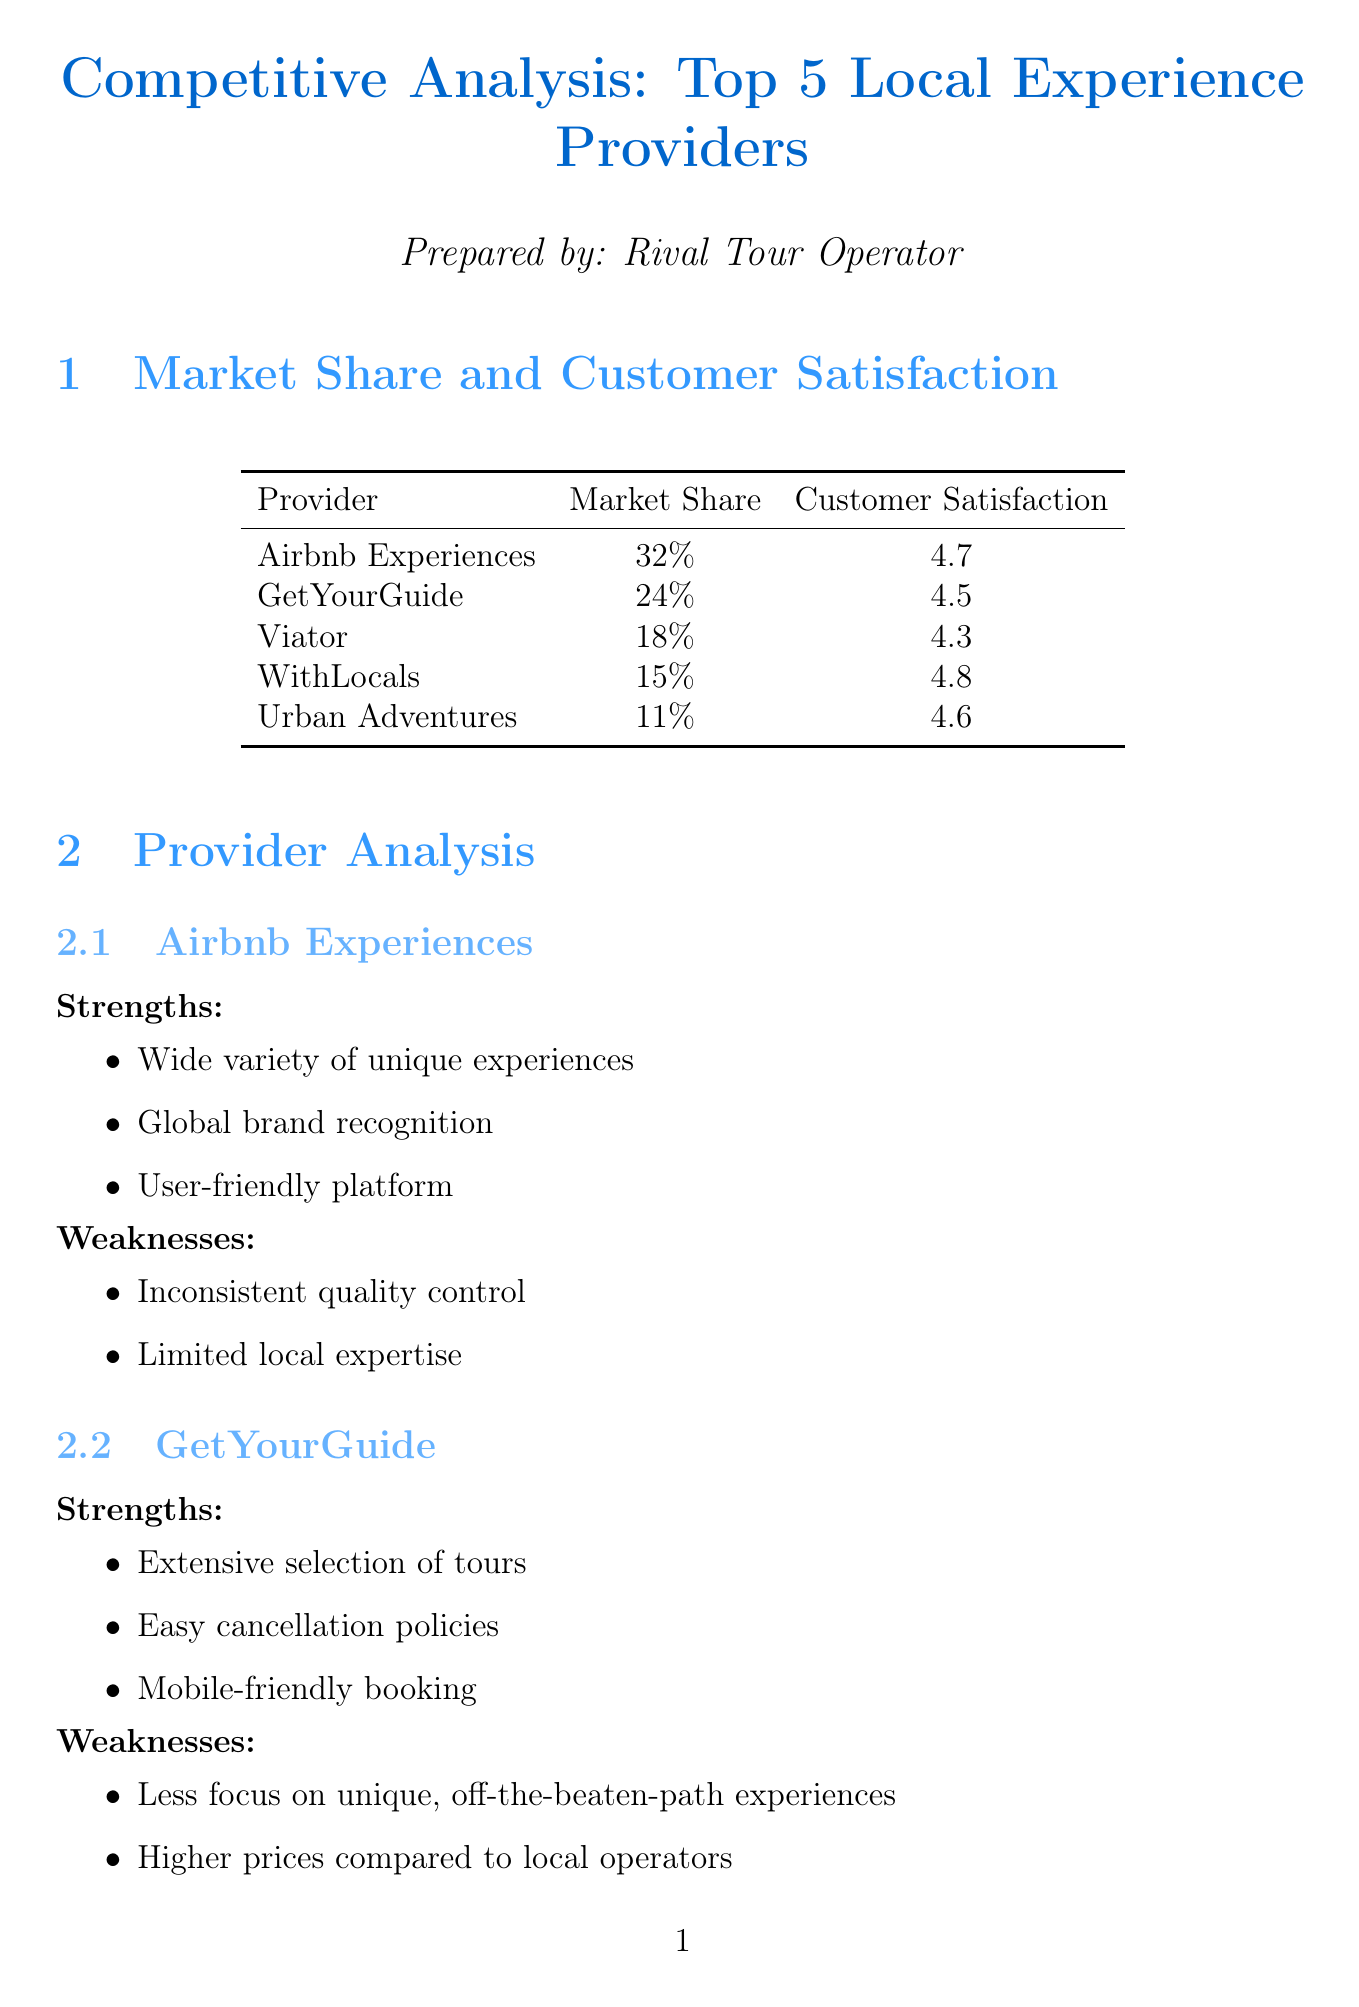What is the market share of Airbnb Experiences? The market share of Airbnb Experiences is explicitly stated in the document.
Answer: 32% Which provider has the highest customer satisfaction rating? The customer satisfaction ratings for each provider are listed, and the highest rating can be directly identified.
Answer: WithLocals What is one strength of GetYourGuide? The strengths for each provider are listed, and any one strength can be cited.
Answer: Extensive selection of tours What percentage of the market share does Viator hold? The market share for each provider is included and can be directly referenced.
Answer: 18% What is a common theme in customer preferences? Customer preferences are detailed, and a common theme can be inferred from the list.
Answer: Authentic local interactions Which provider focuses on responsible tourism? The strengths for each provider include specific focuses, and this can be directly answered from the document.
Answer: Urban Adventures What is an opportunity for differentiation mentioned in the report? Opportunities for differentiation are listed, allowing for a direct extraction of one item.
Answer: Focusing on hyper-local, off-the-beaten-path experiences What is one potential challenge mentioned? Potential challenges are outlined in the document, and one can be identified easily.
Answer: Intense competition from established players What is the market share of Urban Adventures? The document provides the market shares of each provider, making this easily retrievable.
Answer: 11% 